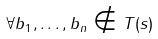<formula> <loc_0><loc_0><loc_500><loc_500>\forall b _ { 1 } , \dots , b _ { n } \notin T ( s )</formula> 